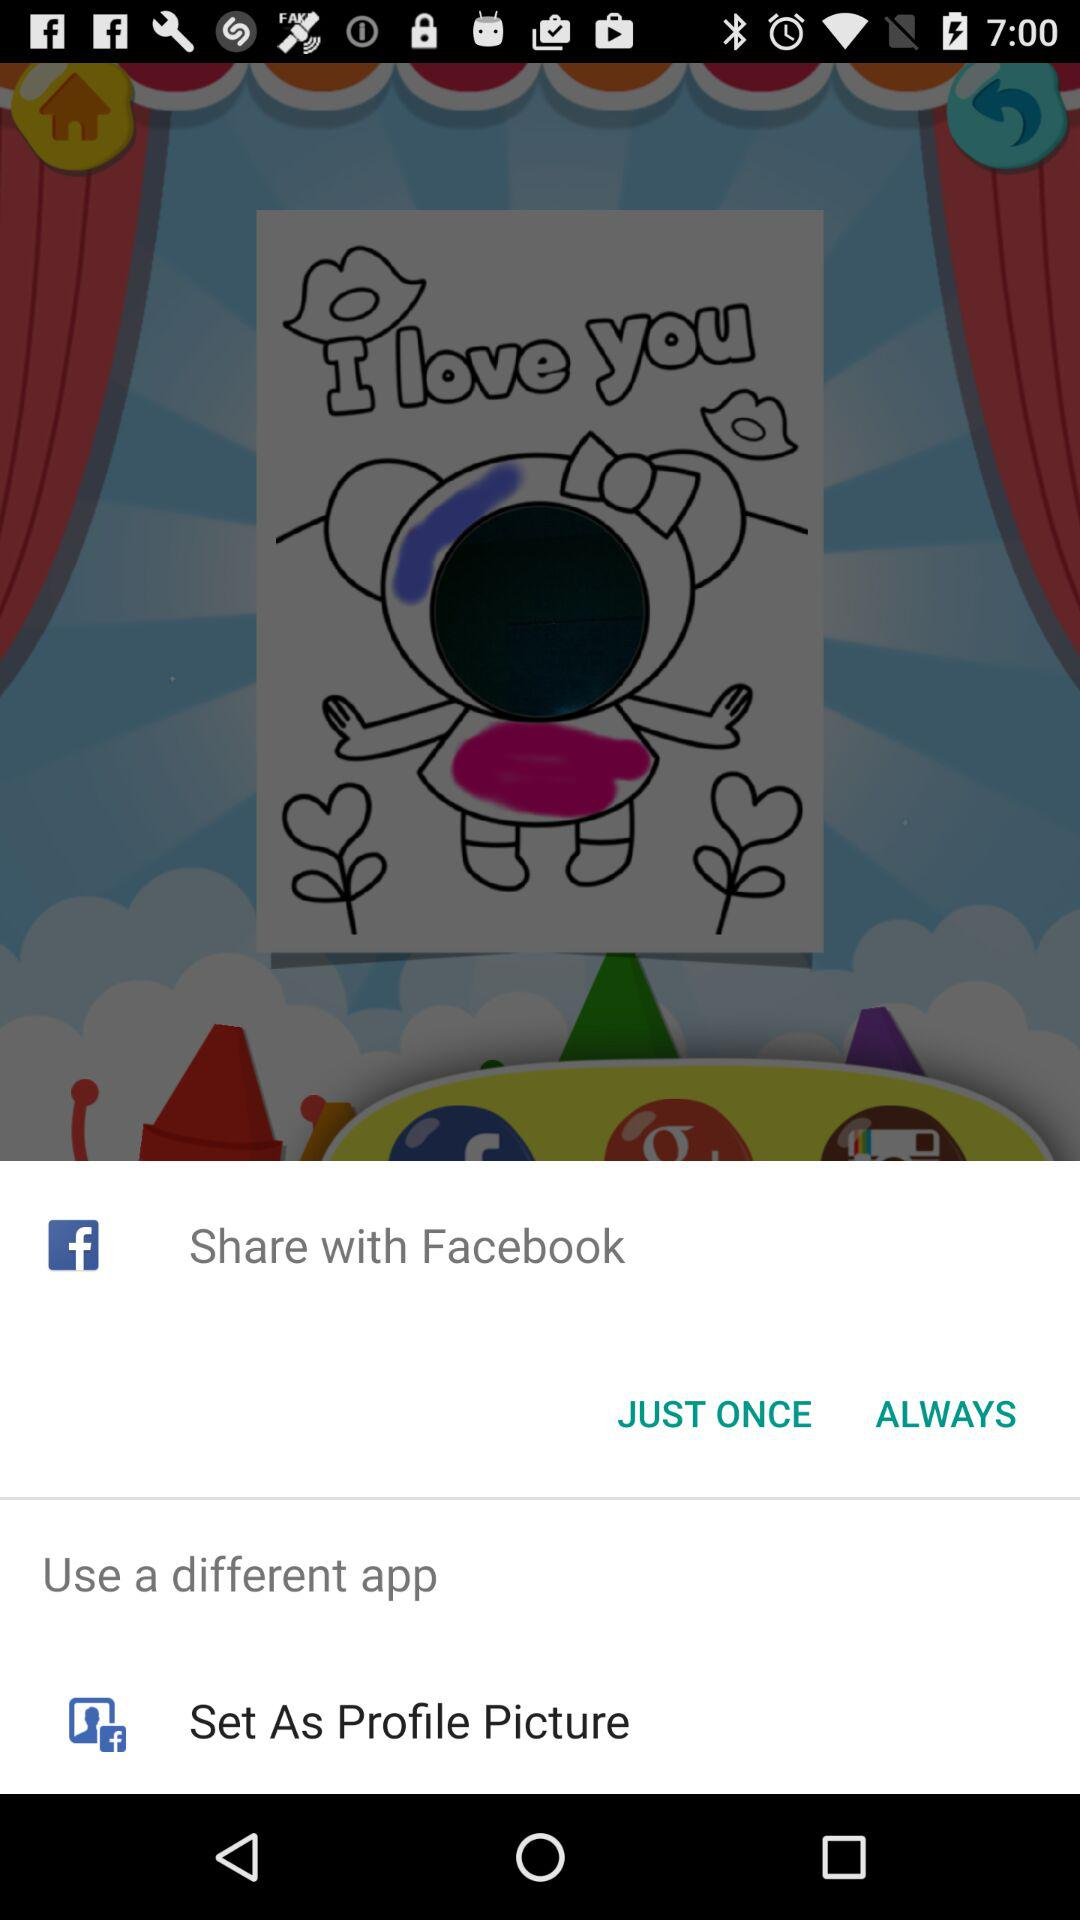What different applications can I use? You can use Facebook. 